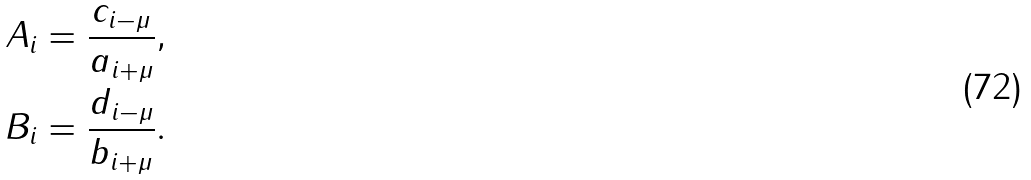Convert formula to latex. <formula><loc_0><loc_0><loc_500><loc_500>A _ { i } & = \frac { c _ { i - \mu } } { a _ { i + \mu } } , \\ B _ { i } & = \frac { d _ { i - \mu } } { b _ { i + \mu } } .</formula> 